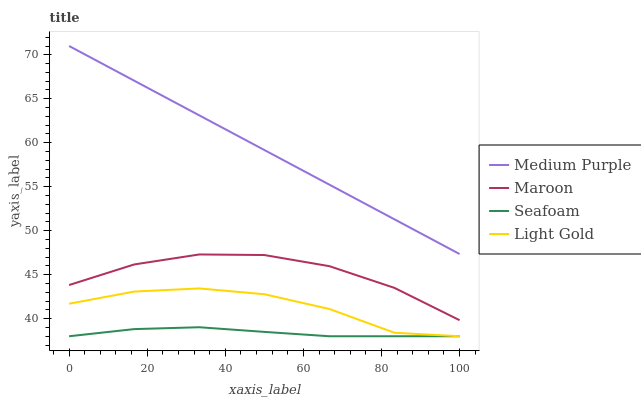Does Seafoam have the minimum area under the curve?
Answer yes or no. Yes. Does Medium Purple have the maximum area under the curve?
Answer yes or no. Yes. Does Light Gold have the minimum area under the curve?
Answer yes or no. No. Does Light Gold have the maximum area under the curve?
Answer yes or no. No. Is Medium Purple the smoothest?
Answer yes or no. Yes. Is Light Gold the roughest?
Answer yes or no. Yes. Is Seafoam the smoothest?
Answer yes or no. No. Is Seafoam the roughest?
Answer yes or no. No. Does Light Gold have the lowest value?
Answer yes or no. Yes. Does Maroon have the lowest value?
Answer yes or no. No. Does Medium Purple have the highest value?
Answer yes or no. Yes. Does Light Gold have the highest value?
Answer yes or no. No. Is Light Gold less than Maroon?
Answer yes or no. Yes. Is Medium Purple greater than Seafoam?
Answer yes or no. Yes. Does Seafoam intersect Light Gold?
Answer yes or no. Yes. Is Seafoam less than Light Gold?
Answer yes or no. No. Is Seafoam greater than Light Gold?
Answer yes or no. No. Does Light Gold intersect Maroon?
Answer yes or no. No. 